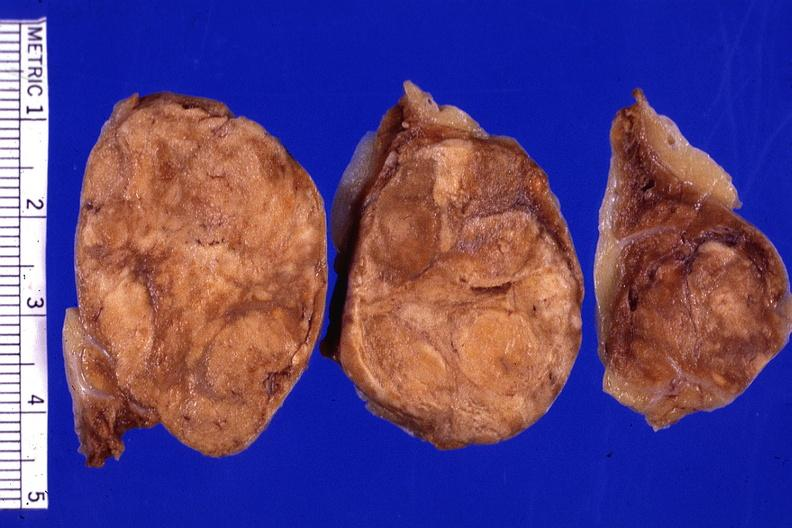does coronary artery show cut surface 3 cm lesion very good?
Answer the question using a single word or phrase. No 